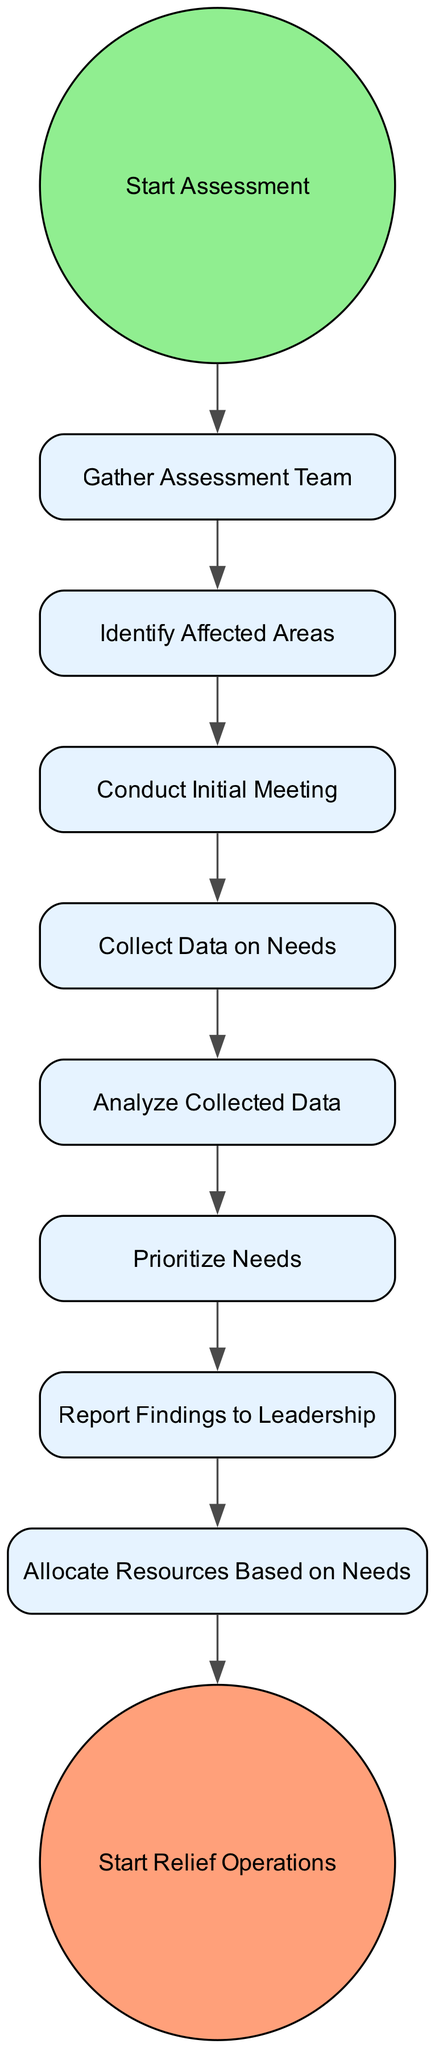What is the first activity in the assessment process? The first activity is indicated as a start event, which is "Start Assessment." This is the initial step in the diagram before any other activities take place.
Answer: Start Assessment How many activities are in the assessment process? By counting the nodes representing activities in the diagram, we see that there are nine activities total, including the start and end events.
Answer: Nine What is the last activity before starting relief operations? The last activity leading to "Start Relief Operations" is "Allocate Resources Based on Needs." This is the final step before transitioning to the end event of the process.
Answer: Allocate Resources Based on Needs What activity comes after conducting the initial meeting? After "Conduct Initial Meeting," the next activity specified in the transitions is "Collect Data on Needs." This indicates a sequential movement to data collection following the meeting.
Answer: Collect Data on Needs Which activity directly follows analyzing collected data? The activity that directly follows "Analyze Collected Data" is "Prioritize Needs." This shows the logical flow from data analysis to determining priorities.
Answer: Prioritize Needs How many transitions are present in the diagram? There are eight transitions that connect the activities in the diagram, indicating the flow from one step to the next throughout the assessment process.
Answer: Eight What is the nature of the activity "Report Findings to Leadership"? "Report Findings to Leadership" is classified as an activity in the diagram that involves communication of analyzed data. It is one of the primary steps in concluding the assessment before resource allocation.
Answer: Activity What indicates the conclusion of the assessment process? The diagram indicates the conclusion of the assessment process with an end event labeled "Start Relief Operations." This signifies the transition from assessment to action.
Answer: Start Relief Operations What is the purpose of "Prioritize Needs" in the diagram? The purpose of "Prioritize Needs" is to organize and rank the needs identified in the assessment, ensuring that the most critical requirements are addressed first in the subsequent relief operations.
Answer: Organizing needs 